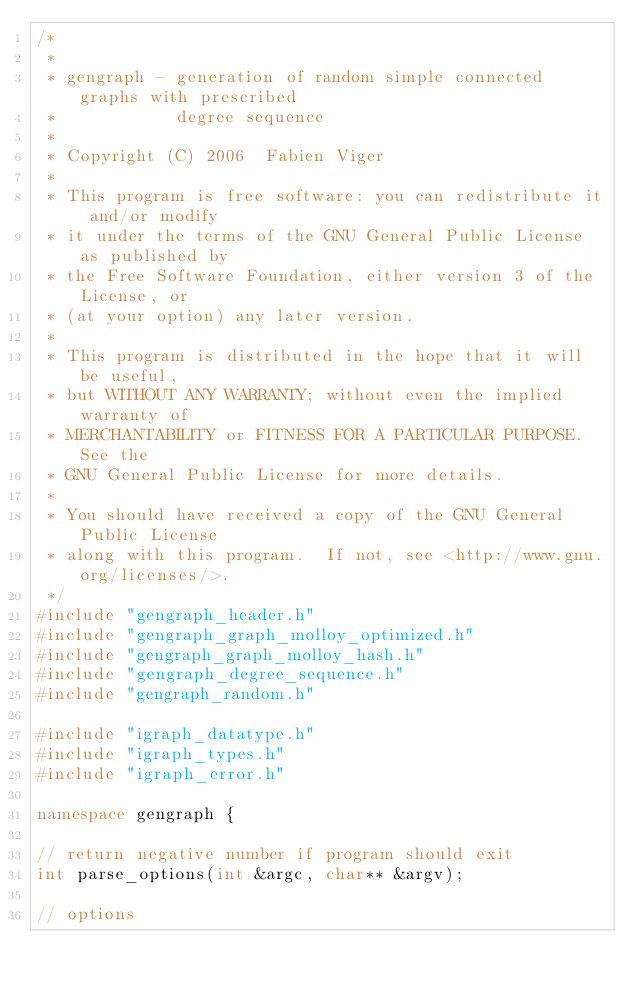<code> <loc_0><loc_0><loc_500><loc_500><_C++_>/*
 *
 * gengraph - generation of random simple connected graphs with prescribed
 *            degree sequence
 *
 * Copyright (C) 2006  Fabien Viger
 *
 * This program is free software: you can redistribute it and/or modify
 * it under the terms of the GNU General Public License as published by
 * the Free Software Foundation, either version 3 of the License, or
 * (at your option) any later version.
 *
 * This program is distributed in the hope that it will be useful,
 * but WITHOUT ANY WARRANTY; without even the implied warranty of
 * MERCHANTABILITY or FITNESS FOR A PARTICULAR PURPOSE.  See the
 * GNU General Public License for more details.
 *
 * You should have received a copy of the GNU General Public License
 * along with this program.  If not, see <http://www.gnu.org/licenses/>.
 */
#include "gengraph_header.h"
#include "gengraph_graph_molloy_optimized.h"
#include "gengraph_graph_molloy_hash.h"
#include "gengraph_degree_sequence.h"
#include "gengraph_random.h"

#include "igraph_datatype.h"
#include "igraph_types.h"
#include "igraph_error.h"

namespace gengraph {

// return negative number if program should exit
int parse_options(int &argc, char** &argv);

// options</code> 